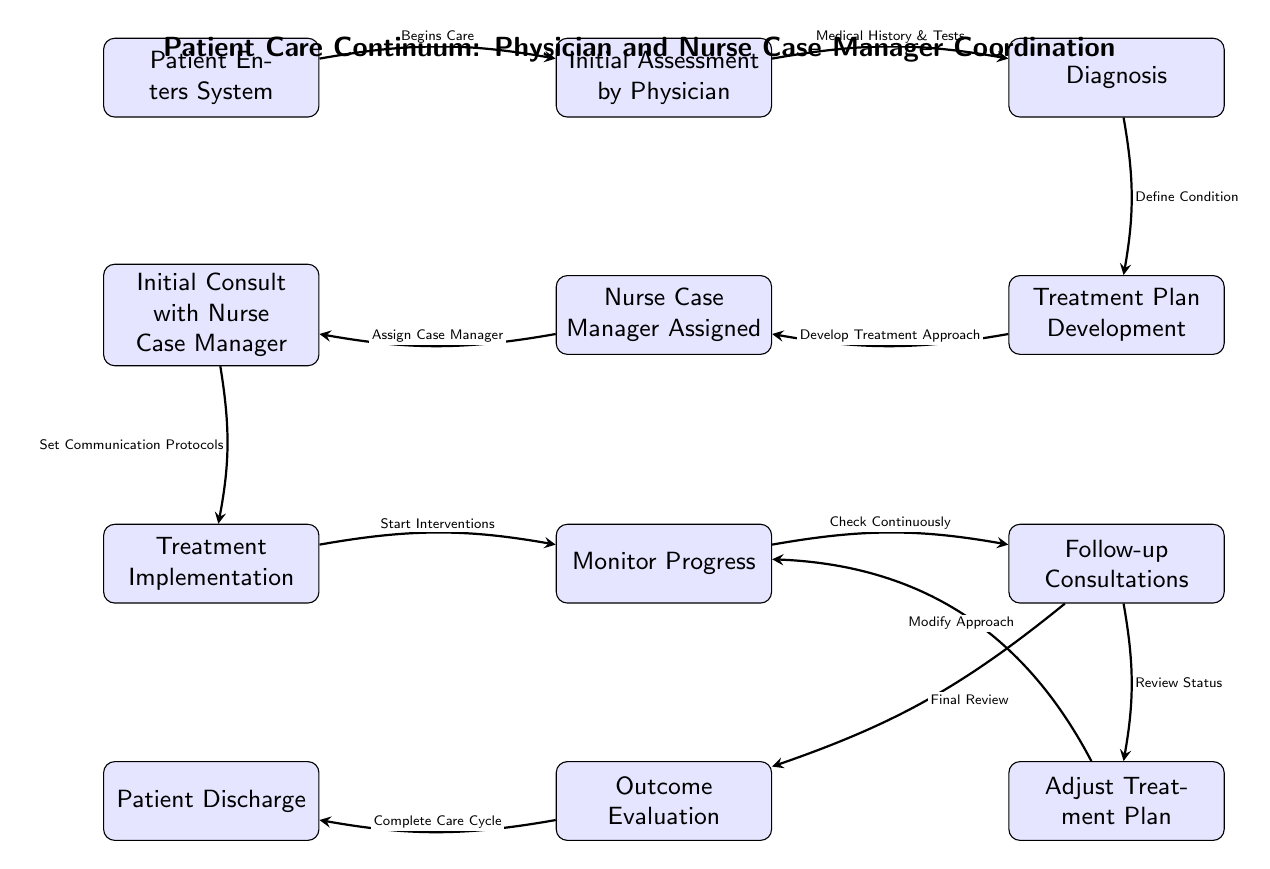What is the first step in the patient care continuum? The diagram starts with the node labeled "Patient Enters System," indicating this is where the process begins.
Answer: Patient Enters System How many nodes are in the diagram? By counting all distinct steps represented in the flowchart, we find there are 12 nodes, each representing a different part of the care continuum.
Answer: 12 What does the "Initial Assessment by Physician" lead to? The arrow from "Initial Assessment by Physician" points directly to the next node, which is labeled "Diagnosis," indicating that the assessment results in a diagnosis.
Answer: Diagnosis Which node follows "Monitor Progress"? According to the diagram, the next node after "Monitor Progress" is "Follow-up Consultations," meaning monitoring leads directly to follow-up consultations.
Answer: Follow-up Consultations What is the purpose of the "Initial Consult with Nurse Case Manager"? The diagram states that the "Initial Consult with Nurse Case Manager" sets communication protocols, which is essential for coordinating care between the physician and case manager.
Answer: Set Communication Protocols What happens after "Adjust Treatment Plan"? The flowchart shows that after "Adjust Treatment Plan," the process circles back to "Monitor Progress," indicating that adjustments lead to further monitoring.
Answer: Monitor Progress What is the last step in the diagram? The final node in the flowchart is labeled "Patient Discharge," which signifies the completion of the care process.
Answer: Patient Discharge How many arrows connect the node "Diagnosis"? There are two arrows leading from the node "Diagnosis," one to "Treatment Plan Development" and another to indicate that it connects with prior assessments made by the physician.
Answer: 2 What responsibility is assigned to the Nurse Case Manager? The flowchart shows that one of the key responsibilities assigned to the Nurse Case Manager is to conduct the "Initial Consult with Nurse Case Manager," outlining the starting point of their involvement.
Answer: Assign Case Manager 